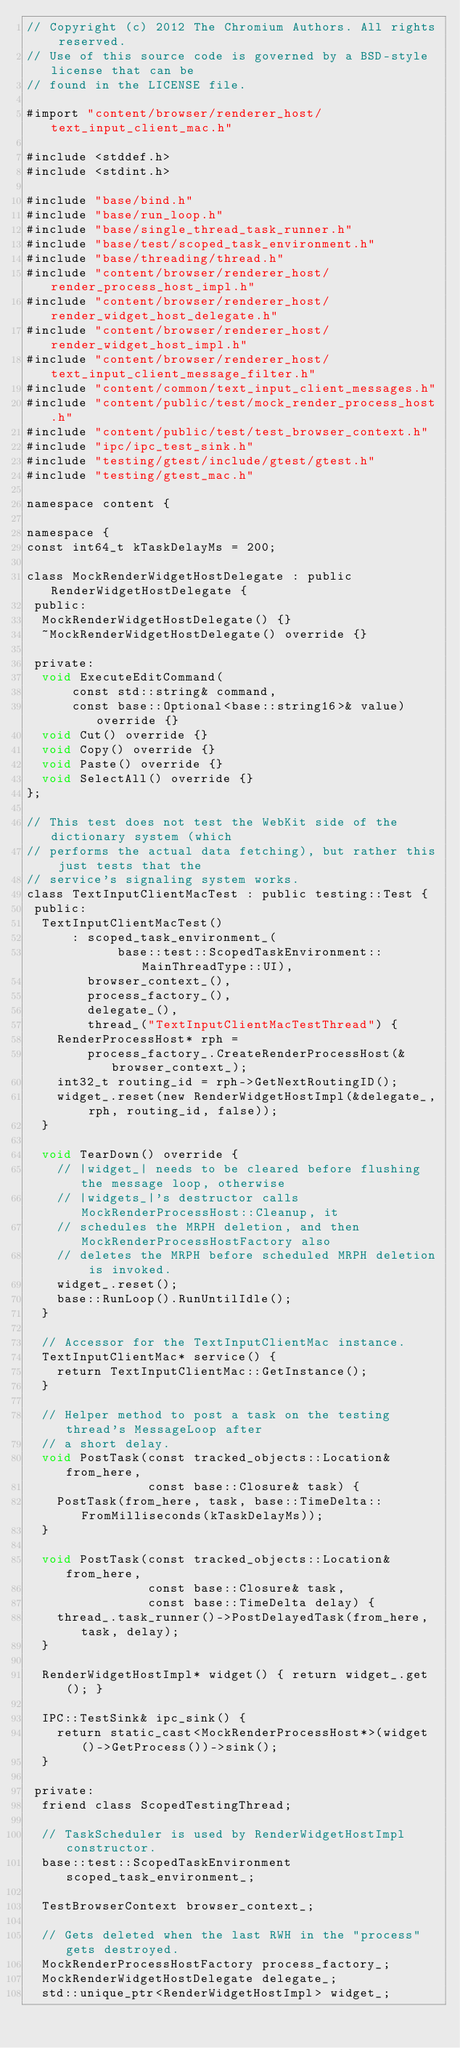<code> <loc_0><loc_0><loc_500><loc_500><_ObjectiveC_>// Copyright (c) 2012 The Chromium Authors. All rights reserved.
// Use of this source code is governed by a BSD-style license that can be
// found in the LICENSE file.

#import "content/browser/renderer_host/text_input_client_mac.h"

#include <stddef.h>
#include <stdint.h>

#include "base/bind.h"
#include "base/run_loop.h"
#include "base/single_thread_task_runner.h"
#include "base/test/scoped_task_environment.h"
#include "base/threading/thread.h"
#include "content/browser/renderer_host/render_process_host_impl.h"
#include "content/browser/renderer_host/render_widget_host_delegate.h"
#include "content/browser/renderer_host/render_widget_host_impl.h"
#include "content/browser/renderer_host/text_input_client_message_filter.h"
#include "content/common/text_input_client_messages.h"
#include "content/public/test/mock_render_process_host.h"
#include "content/public/test/test_browser_context.h"
#include "ipc/ipc_test_sink.h"
#include "testing/gtest/include/gtest/gtest.h"
#include "testing/gtest_mac.h"

namespace content {

namespace {
const int64_t kTaskDelayMs = 200;

class MockRenderWidgetHostDelegate : public RenderWidgetHostDelegate {
 public:
  MockRenderWidgetHostDelegate() {}
  ~MockRenderWidgetHostDelegate() override {}

 private:
  void ExecuteEditCommand(
      const std::string& command,
      const base::Optional<base::string16>& value) override {}
  void Cut() override {}
  void Copy() override {}
  void Paste() override {}
  void SelectAll() override {}
};

// This test does not test the WebKit side of the dictionary system (which
// performs the actual data fetching), but rather this just tests that the
// service's signaling system works.
class TextInputClientMacTest : public testing::Test {
 public:
  TextInputClientMacTest()
      : scoped_task_environment_(
            base::test::ScopedTaskEnvironment::MainThreadType::UI),
        browser_context_(),
        process_factory_(),
        delegate_(),
        thread_("TextInputClientMacTestThread") {
    RenderProcessHost* rph =
        process_factory_.CreateRenderProcessHost(&browser_context_);
    int32_t routing_id = rph->GetNextRoutingID();
    widget_.reset(new RenderWidgetHostImpl(&delegate_, rph, routing_id, false));
  }

  void TearDown() override {
    // |widget_| needs to be cleared before flushing the message loop, otherwise
    // |widgets_|'s destructor calls MockRenderProcessHost::Cleanup, it
    // schedules the MRPH deletion, and then MockRenderProcessHostFactory also
    // deletes the MRPH before scheduled MRPH deletion is invoked.
    widget_.reset();
    base::RunLoop().RunUntilIdle();
  }

  // Accessor for the TextInputClientMac instance.
  TextInputClientMac* service() {
    return TextInputClientMac::GetInstance();
  }

  // Helper method to post a task on the testing thread's MessageLoop after
  // a short delay.
  void PostTask(const tracked_objects::Location& from_here,
                const base::Closure& task) {
    PostTask(from_here, task, base::TimeDelta::FromMilliseconds(kTaskDelayMs));
  }

  void PostTask(const tracked_objects::Location& from_here,
                const base::Closure& task,
                const base::TimeDelta delay) {
    thread_.task_runner()->PostDelayedTask(from_here, task, delay);
  }

  RenderWidgetHostImpl* widget() { return widget_.get(); }

  IPC::TestSink& ipc_sink() {
    return static_cast<MockRenderProcessHost*>(widget()->GetProcess())->sink();
  }

 private:
  friend class ScopedTestingThread;

  // TaskScheduler is used by RenderWidgetHostImpl constructor.
  base::test::ScopedTaskEnvironment scoped_task_environment_;

  TestBrowserContext browser_context_;

  // Gets deleted when the last RWH in the "process" gets destroyed.
  MockRenderProcessHostFactory process_factory_;
  MockRenderWidgetHostDelegate delegate_;
  std::unique_ptr<RenderWidgetHostImpl> widget_;
</code> 